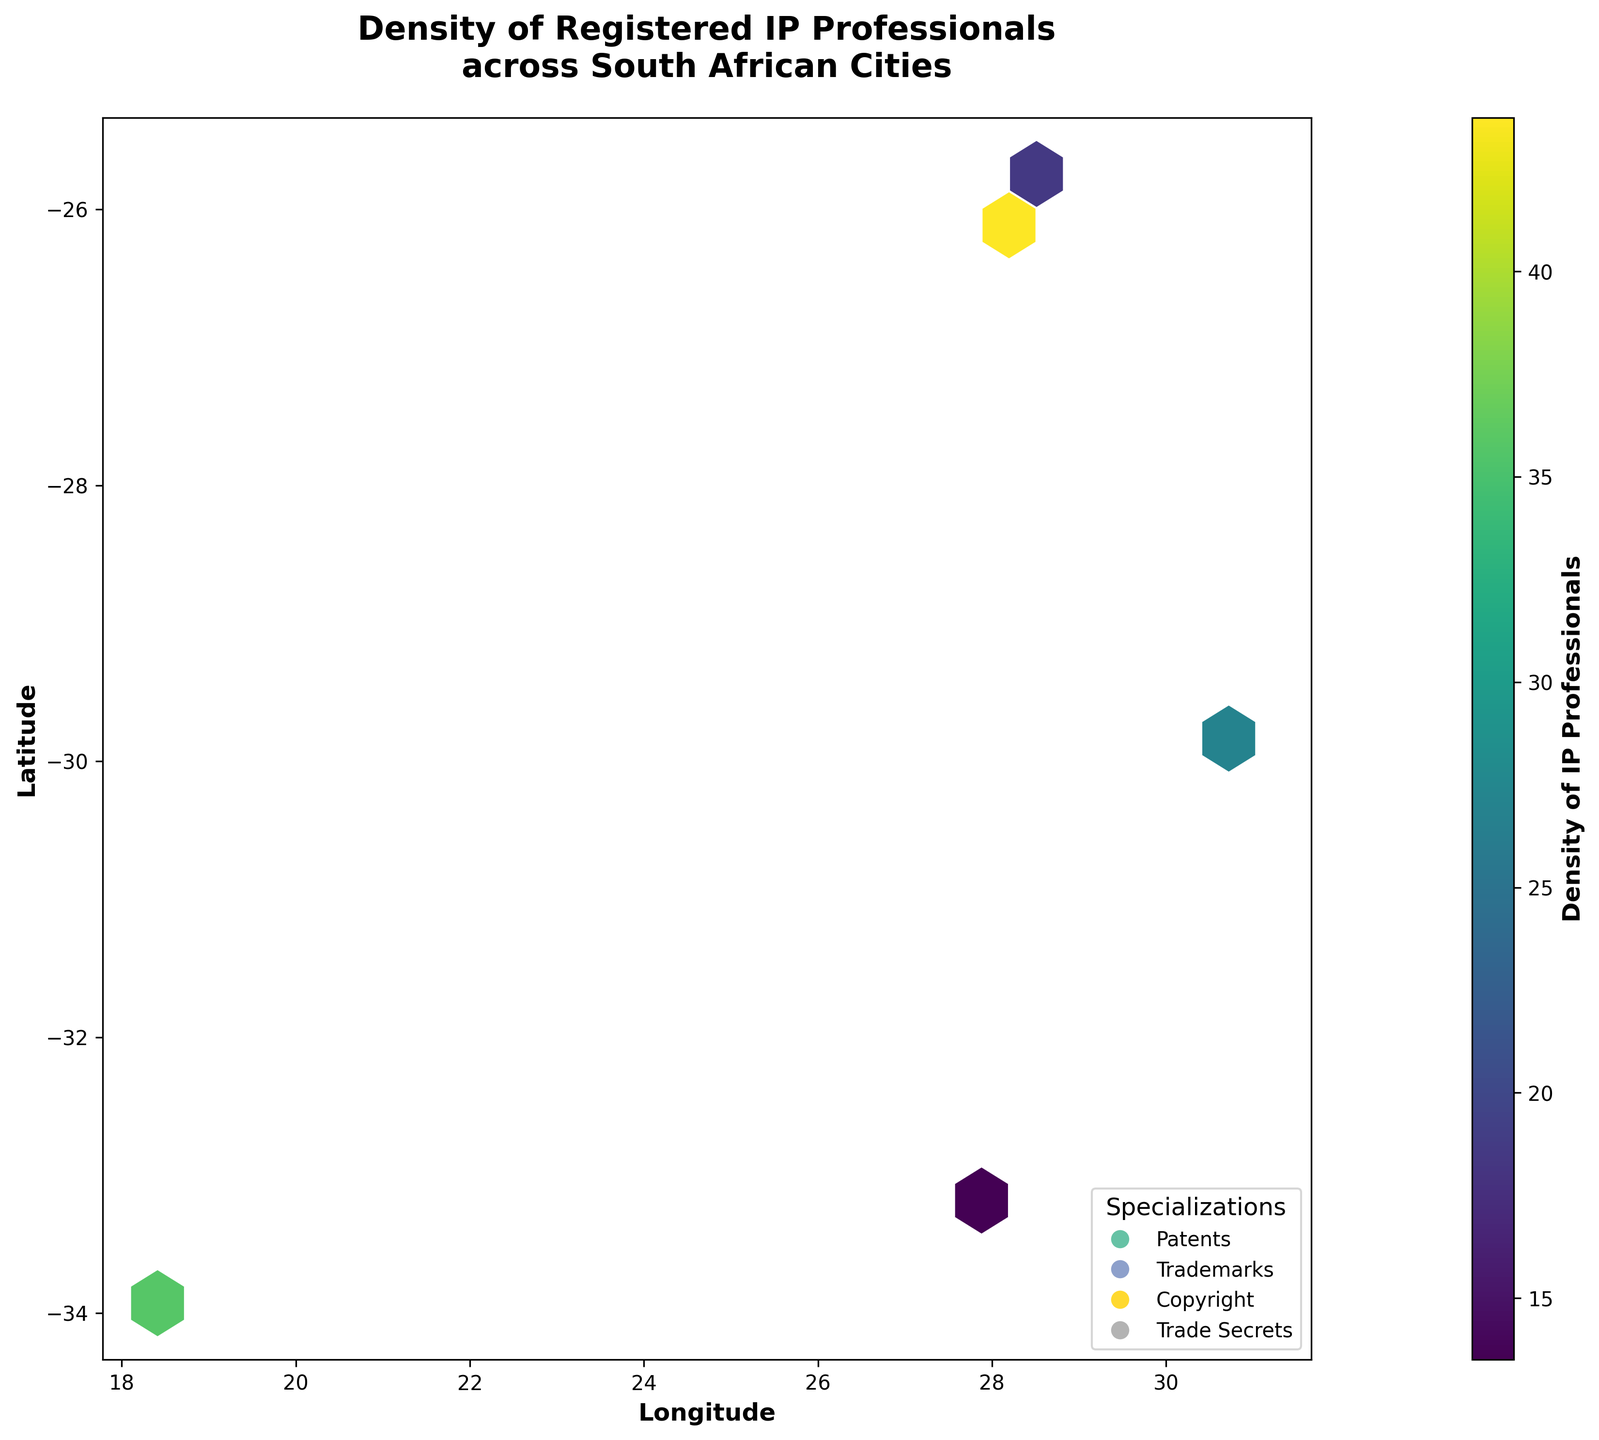How many cities are labelled on the map? There are city labels added to the map. Each city's name is displayed with a small box around it. Counting these annotations will give us the total number of labelled cities.
Answer: 5 Which city has the highest density of registered IP professionals? By examining the color intensity and the colorbar, we see that Johannesburg is associated with the highest density since it has the darkest hexagons.
Answer: Johannesburg What's the longitude range covered in the plot? Observing the x-axis labels, we notice that the longitude ranges from approximately 18 to 31 degrees.
Answer: 18 to 31 Which specialization appears to be the most common? Based on the legend, most hexagons colored according to the specialization in the denser regions indicate that "Patents" is the specialization with the most frequent representation.
Answer: Patents Compare the density of registered IP professionals between Cape Town and Durban. Looking at the color intensity of hexagons around these two cities and correlating it with the colorbar, Johannesburg (52, 47, 41, 35) has overall higher density compared to Durban (33, 29, 25, 21).
Answer: Cape Town has higher density than Durban Which city among Cape Town, Johannesburg, Durban, East London, and Pretoria has the lowest density? Checking the color intensity of hexagons and correlating it with the colorbar reveals East London (18, 15, 12, 9) as the city with the lowest densities.
Answer: East London What is the title of the plot? The title is shown at the top center of the plot in a larger, bold font.
Answer: Density of Registered IP Professionals across South African Cities Identify the specializations used in the plot and their corresponding color codes. The legend at the lower right corner defines colors for specializations. The colors differentiate 'Patents', 'Trademarks', 'Copyright', 'Trade Secrets'.
Answer: Patents, Trademarks, Copyright, Trade Secrets 